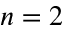<formula> <loc_0><loc_0><loc_500><loc_500>n = 2</formula> 